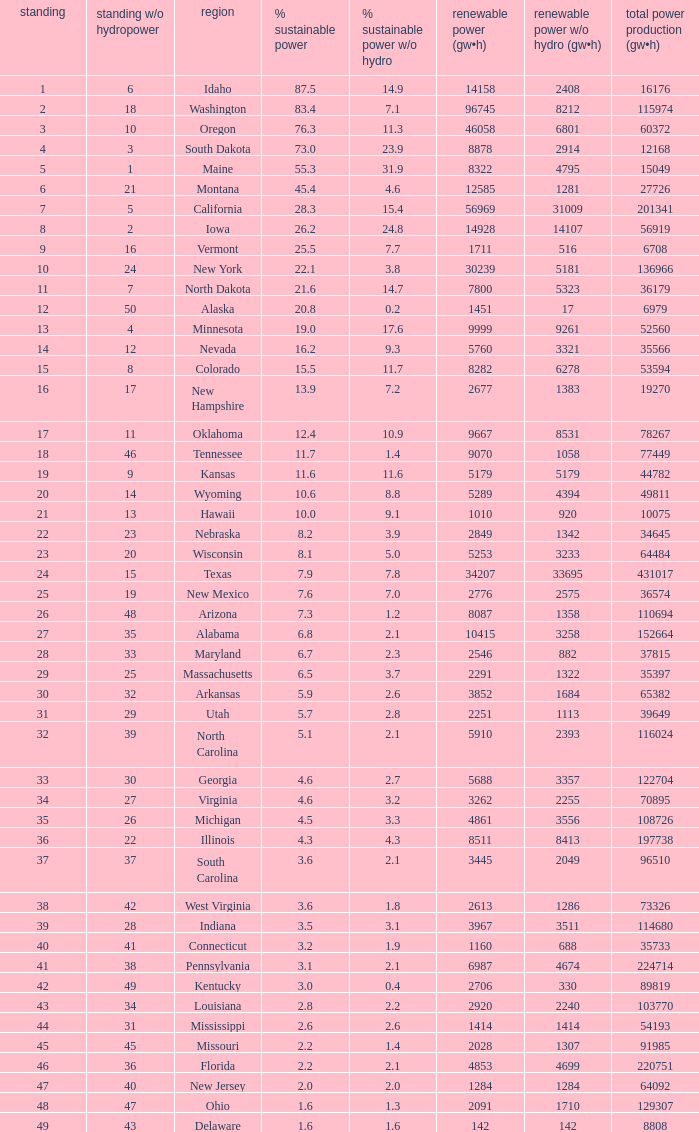Help me parse the entirety of this table. {'header': ['standing', 'standing w/o hydropower', 'region', '% sustainable power', '% sustainable power w/o hydro', 'renewable power (gw•h)', 'renewable power w/o hydro (gw•h)', 'total power production (gw•h)'], 'rows': [['1', '6', 'Idaho', '87.5', '14.9', '14158', '2408', '16176'], ['2', '18', 'Washington', '83.4', '7.1', '96745', '8212', '115974'], ['3', '10', 'Oregon', '76.3', '11.3', '46058', '6801', '60372'], ['4', '3', 'South Dakota', '73.0', '23.9', '8878', '2914', '12168'], ['5', '1', 'Maine', '55.3', '31.9', '8322', '4795', '15049'], ['6', '21', 'Montana', '45.4', '4.6', '12585', '1281', '27726'], ['7', '5', 'California', '28.3', '15.4', '56969', '31009', '201341'], ['8', '2', 'Iowa', '26.2', '24.8', '14928', '14107', '56919'], ['9', '16', 'Vermont', '25.5', '7.7', '1711', '516', '6708'], ['10', '24', 'New York', '22.1', '3.8', '30239', '5181', '136966'], ['11', '7', 'North Dakota', '21.6', '14.7', '7800', '5323', '36179'], ['12', '50', 'Alaska', '20.8', '0.2', '1451', '17', '6979'], ['13', '4', 'Minnesota', '19.0', '17.6', '9999', '9261', '52560'], ['14', '12', 'Nevada', '16.2', '9.3', '5760', '3321', '35566'], ['15', '8', 'Colorado', '15.5', '11.7', '8282', '6278', '53594'], ['16', '17', 'New Hampshire', '13.9', '7.2', '2677', '1383', '19270'], ['17', '11', 'Oklahoma', '12.4', '10.9', '9667', '8531', '78267'], ['18', '46', 'Tennessee', '11.7', '1.4', '9070', '1058', '77449'], ['19', '9', 'Kansas', '11.6', '11.6', '5179', '5179', '44782'], ['20', '14', 'Wyoming', '10.6', '8.8', '5289', '4394', '49811'], ['21', '13', 'Hawaii', '10.0', '9.1', '1010', '920', '10075'], ['22', '23', 'Nebraska', '8.2', '3.9', '2849', '1342', '34645'], ['23', '20', 'Wisconsin', '8.1', '5.0', '5253', '3233', '64484'], ['24', '15', 'Texas', '7.9', '7.8', '34207', '33695', '431017'], ['25', '19', 'New Mexico', '7.6', '7.0', '2776', '2575', '36574'], ['26', '48', 'Arizona', '7.3', '1.2', '8087', '1358', '110694'], ['27', '35', 'Alabama', '6.8', '2.1', '10415', '3258', '152664'], ['28', '33', 'Maryland', '6.7', '2.3', '2546', '882', '37815'], ['29', '25', 'Massachusetts', '6.5', '3.7', '2291', '1322', '35397'], ['30', '32', 'Arkansas', '5.9', '2.6', '3852', '1684', '65382'], ['31', '29', 'Utah', '5.7', '2.8', '2251', '1113', '39649'], ['32', '39', 'North Carolina', '5.1', '2.1', '5910', '2393', '116024'], ['33', '30', 'Georgia', '4.6', '2.7', '5688', '3357', '122704'], ['34', '27', 'Virginia', '4.6', '3.2', '3262', '2255', '70895'], ['35', '26', 'Michigan', '4.5', '3.3', '4861', '3556', '108726'], ['36', '22', 'Illinois', '4.3', '4.3', '8511', '8413', '197738'], ['37', '37', 'South Carolina', '3.6', '2.1', '3445', '2049', '96510'], ['38', '42', 'West Virginia', '3.6', '1.8', '2613', '1286', '73326'], ['39', '28', 'Indiana', '3.5', '3.1', '3967', '3511', '114680'], ['40', '41', 'Connecticut', '3.2', '1.9', '1160', '688', '35733'], ['41', '38', 'Pennsylvania', '3.1', '2.1', '6987', '4674', '224714'], ['42', '49', 'Kentucky', '3.0', '0.4', '2706', '330', '89819'], ['43', '34', 'Louisiana', '2.8', '2.2', '2920', '2240', '103770'], ['44', '31', 'Mississippi', '2.6', '2.6', '1414', '1414', '54193'], ['45', '45', 'Missouri', '2.2', '1.4', '2028', '1307', '91985'], ['46', '36', 'Florida', '2.2', '2.1', '4853', '4699', '220751'], ['47', '40', 'New Jersey', '2.0', '2.0', '1284', '1284', '64092'], ['48', '47', 'Ohio', '1.6', '1.3', '2091', '1710', '129307'], ['49', '43', 'Delaware', '1.6', '1.6', '142', '142', '8808']]} What is the percentage of renewable electricity without hydrogen power in the state of South Dakota? 23.9. 